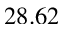Convert formula to latex. <formula><loc_0><loc_0><loc_500><loc_500>2 8 . 6 2</formula> 